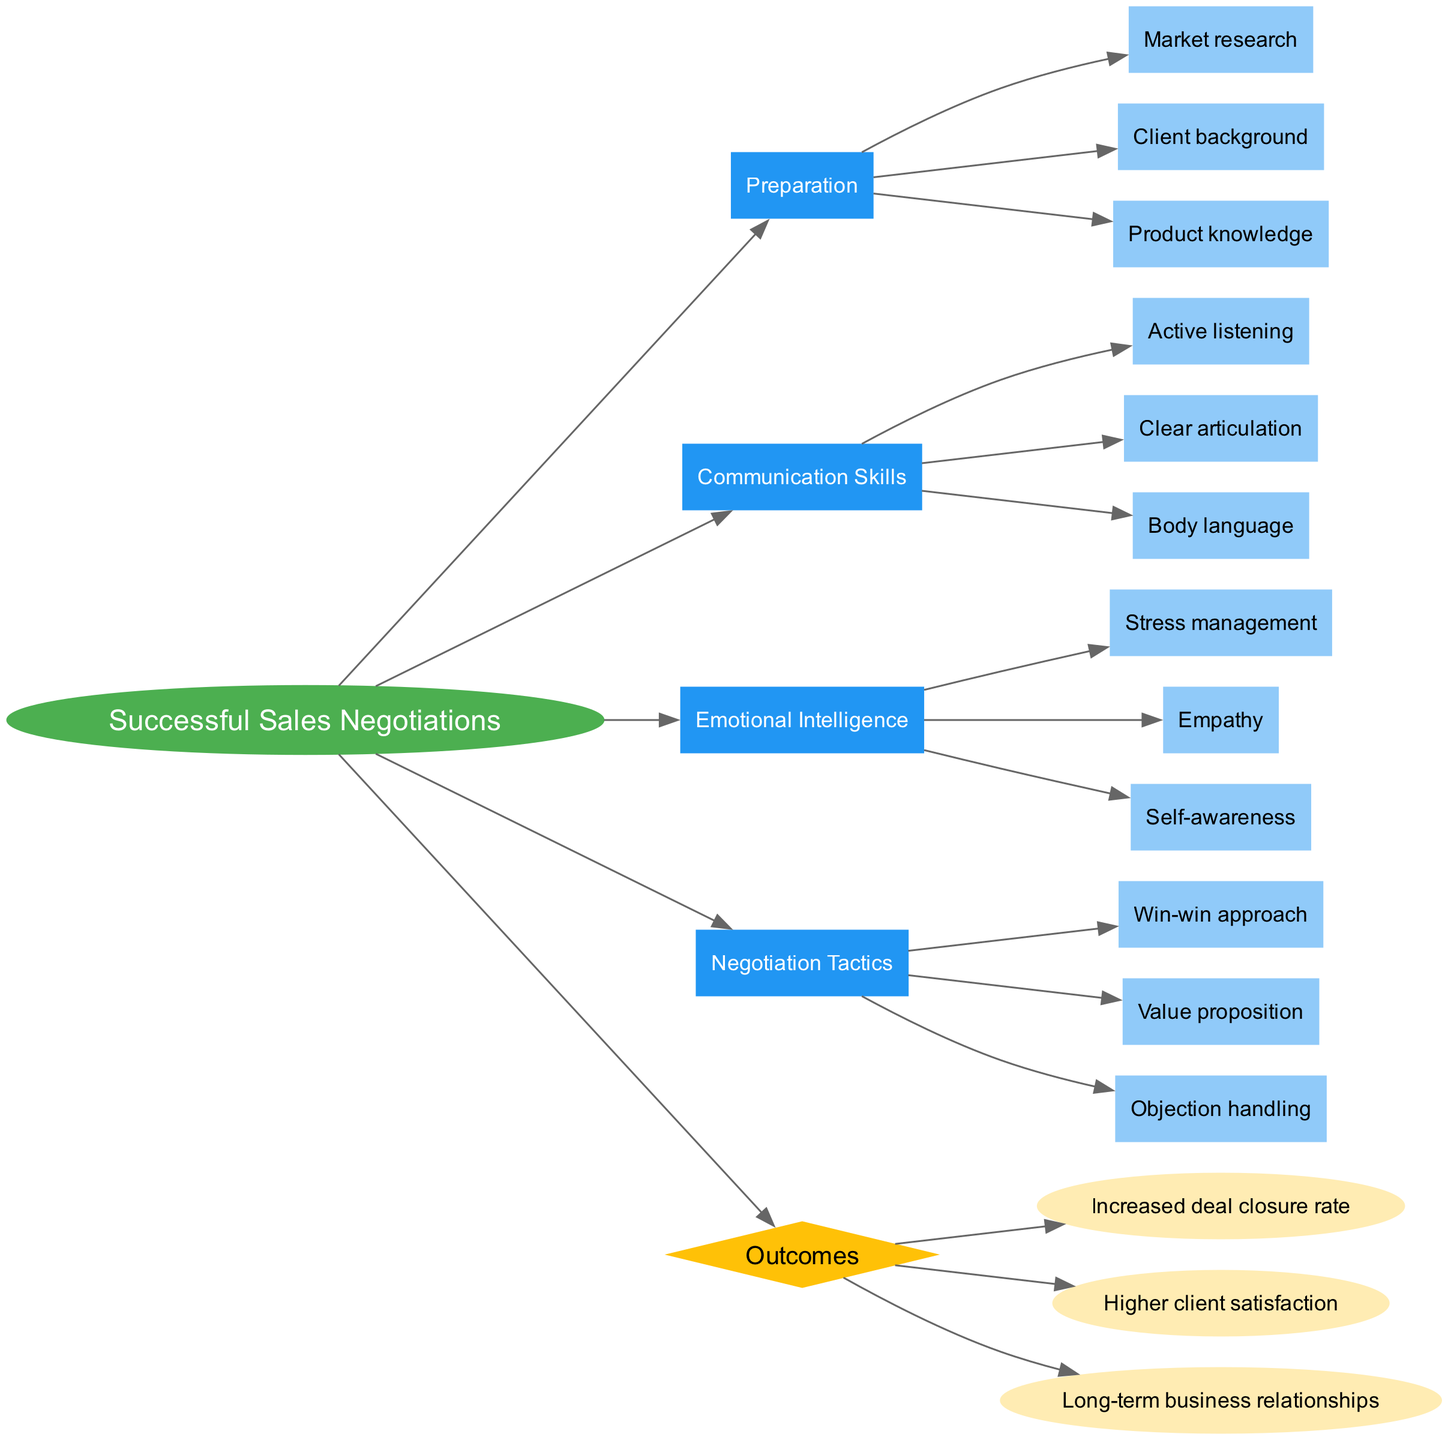What is the central topic of the diagram? The central topic is explicitly labeled in the diagram as "Successful Sales Negotiations." This is identified by the ellipse shape at the center of the diagram.
Answer: Successful Sales Negotiations How many main factors are contributing to successful sales negotiations? By examining the nodes directly connected to the central topic, there are four main factors: Preparation, Communication Skills, Emotional Intelligence, and Negotiation Tactics.
Answer: 4 What is one of the sub-factors under 'Emotional Intelligence'? The sub-factors under 'Emotional Intelligence' are connected to that factor’s node. Stress management, Empathy, and Self-awareness are all listed as sub-factors. One such sub-factor is Stress management.
Answer: Stress management Which outcome is directly linked to the central topic? The diagram indicates an outcome node labeled 'Outcomes' that branches from the central topic 'Successful Sales Negotiations.' This outcome node further leads to specific outcomes such as Increased deal closure rate, Higher client satisfaction, etc.
Answer: Outcomes What is the relationship between 'Preparation' and 'Market research'? In the diagram, 'Preparation' is a main factor, and 'Market research' is a sub-factor connected to it. The sub-node shows that 'Market research' is part of the preparation process for successful sales negotiations.
Answer: Preparation -> Market research How many outcomes are shown in the diagram? The outcomes, listed beneath the 'Outcomes' node, include three distinct items: Increased deal closure rate, Higher client satisfaction, and Long-term business relationships, leading to a direct count of the outcomes present.
Answer: 3 What is a negotiation tactic listed in the diagram? The 'Negotiation Tactics' node has sub-factors connected to it, one of which is the 'Win-win approach.' This indicates that it is considered a negotiation tactic for achieving successful sales negotiations.
Answer: Win-win approach How does 'Emotional Intelligence' influence outcomes? The diagram illustrates that 'Emotional Intelligence' is one of the key main factors linked to the central topic. It implies that effective management of emotions can lead to better outcomes in sales negotiations, suggesting a cause-and-effect relationship.
Answer: Influences outcomes positively Which main factor has 'Body language' as a sub-factor? The node titled 'Communication Skills' is directly associated with 'Body language' as one of its sub-factors, indicating that it plays a role in effective communication during negotiations.
Answer: Communication Skills 